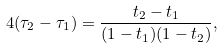Convert formula to latex. <formula><loc_0><loc_0><loc_500><loc_500>4 ( \tau _ { 2 } - \tau _ { 1 } ) = \frac { t _ { 2 } - t _ { 1 } } { ( 1 - t _ { 1 } ) ( 1 - t _ { 2 } ) } ,</formula> 